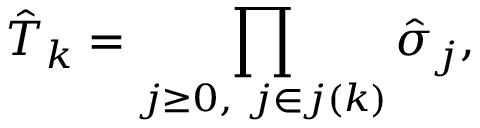<formula> <loc_0><loc_0><loc_500><loc_500>\hat { T } _ { k } = \prod _ { j \geq 0 , \ j \in j ( k ) } \hat { \sigma } _ { j } ,</formula> 